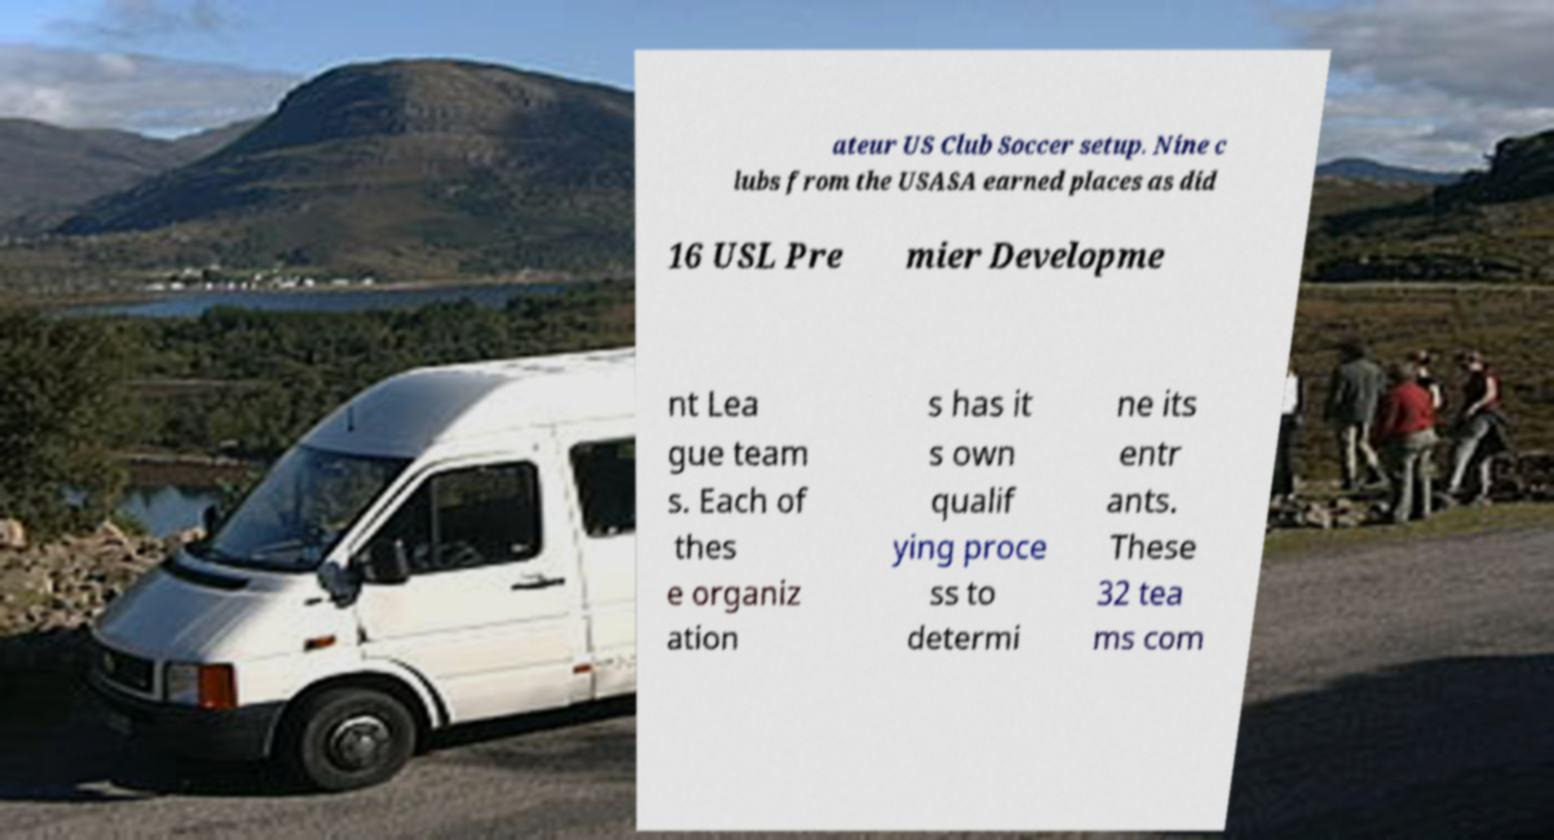Can you read and provide the text displayed in the image?This photo seems to have some interesting text. Can you extract and type it out for me? ateur US Club Soccer setup. Nine c lubs from the USASA earned places as did 16 USL Pre mier Developme nt Lea gue team s. Each of thes e organiz ation s has it s own qualif ying proce ss to determi ne its entr ants. These 32 tea ms com 